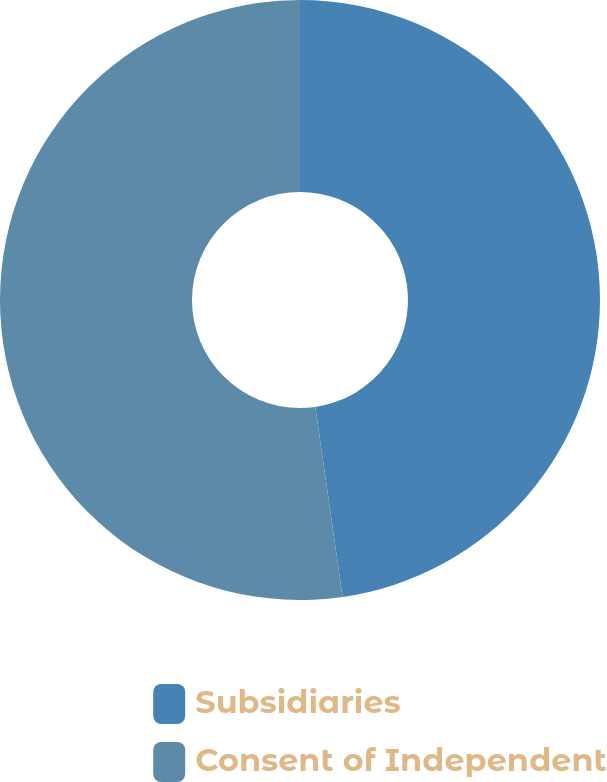Convert chart to OTSL. <chart><loc_0><loc_0><loc_500><loc_500><pie_chart><fcel>Subsidiaries<fcel>Consent of Independent<nl><fcel>47.73%<fcel>52.27%<nl></chart> 